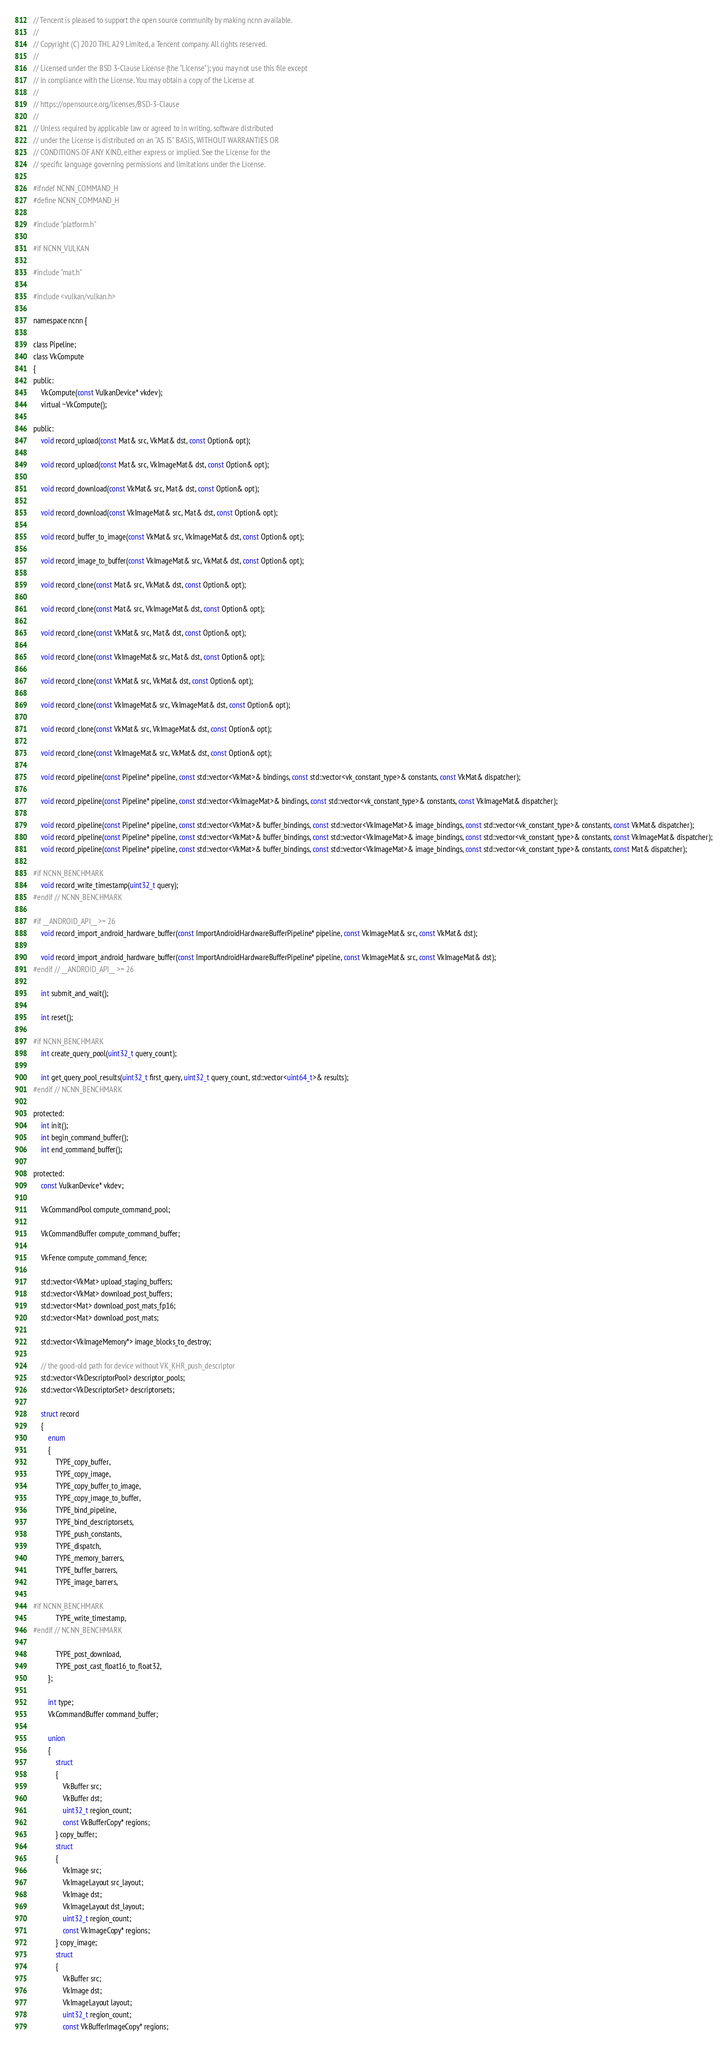<code> <loc_0><loc_0><loc_500><loc_500><_C_>// Tencent is pleased to support the open source community by making ncnn available.
//
// Copyright (C) 2020 THL A29 Limited, a Tencent company. All rights reserved.
//
// Licensed under the BSD 3-Clause License (the "License"); you may not use this file except
// in compliance with the License. You may obtain a copy of the License at
//
// https://opensource.org/licenses/BSD-3-Clause
//
// Unless required by applicable law or agreed to in writing, software distributed
// under the License is distributed on an "AS IS" BASIS, WITHOUT WARRANTIES OR
// CONDITIONS OF ANY KIND, either express or implied. See the License for the
// specific language governing permissions and limitations under the License.

#ifndef NCNN_COMMAND_H
#define NCNN_COMMAND_H

#include "platform.h"

#if NCNN_VULKAN

#include "mat.h"

#include <vulkan/vulkan.h>

namespace ncnn {

class Pipeline;
class VkCompute
{
public:
    VkCompute(const VulkanDevice* vkdev);
    virtual ~VkCompute();

public:
    void record_upload(const Mat& src, VkMat& dst, const Option& opt);

    void record_upload(const Mat& src, VkImageMat& dst, const Option& opt);

    void record_download(const VkMat& src, Mat& dst, const Option& opt);

    void record_download(const VkImageMat& src, Mat& dst, const Option& opt);

    void record_buffer_to_image(const VkMat& src, VkImageMat& dst, const Option& opt);

    void record_image_to_buffer(const VkImageMat& src, VkMat& dst, const Option& opt);

    void record_clone(const Mat& src, VkMat& dst, const Option& opt);

    void record_clone(const Mat& src, VkImageMat& dst, const Option& opt);

    void record_clone(const VkMat& src, Mat& dst, const Option& opt);

    void record_clone(const VkImageMat& src, Mat& dst, const Option& opt);

    void record_clone(const VkMat& src, VkMat& dst, const Option& opt);

    void record_clone(const VkImageMat& src, VkImageMat& dst, const Option& opt);

    void record_clone(const VkMat& src, VkImageMat& dst, const Option& opt);

    void record_clone(const VkImageMat& src, VkMat& dst, const Option& opt);

    void record_pipeline(const Pipeline* pipeline, const std::vector<VkMat>& bindings, const std::vector<vk_constant_type>& constants, const VkMat& dispatcher);

    void record_pipeline(const Pipeline* pipeline, const std::vector<VkImageMat>& bindings, const std::vector<vk_constant_type>& constants, const VkImageMat& dispatcher);

    void record_pipeline(const Pipeline* pipeline, const std::vector<VkMat>& buffer_bindings, const std::vector<VkImageMat>& image_bindings, const std::vector<vk_constant_type>& constants, const VkMat& dispatcher);
    void record_pipeline(const Pipeline* pipeline, const std::vector<VkMat>& buffer_bindings, const std::vector<VkImageMat>& image_bindings, const std::vector<vk_constant_type>& constants, const VkImageMat& dispatcher);
    void record_pipeline(const Pipeline* pipeline, const std::vector<VkMat>& buffer_bindings, const std::vector<VkImageMat>& image_bindings, const std::vector<vk_constant_type>& constants, const Mat& dispatcher);

#if NCNN_BENCHMARK
    void record_write_timestamp(uint32_t query);
#endif // NCNN_BENCHMARK

#if __ANDROID_API__ >= 26
    void record_import_android_hardware_buffer(const ImportAndroidHardwareBufferPipeline* pipeline, const VkImageMat& src, const VkMat& dst);

    void record_import_android_hardware_buffer(const ImportAndroidHardwareBufferPipeline* pipeline, const VkImageMat& src, const VkImageMat& dst);
#endif // __ANDROID_API__ >= 26

    int submit_and_wait();

    int reset();

#if NCNN_BENCHMARK
    int create_query_pool(uint32_t query_count);

    int get_query_pool_results(uint32_t first_query, uint32_t query_count, std::vector<uint64_t>& results);
#endif // NCNN_BENCHMARK

protected:
    int init();
    int begin_command_buffer();
    int end_command_buffer();

protected:
    const VulkanDevice* vkdev;

    VkCommandPool compute_command_pool;

    VkCommandBuffer compute_command_buffer;

    VkFence compute_command_fence;

    std::vector<VkMat> upload_staging_buffers;
    std::vector<VkMat> download_post_buffers;
    std::vector<Mat> download_post_mats_fp16;
    std::vector<Mat> download_post_mats;

    std::vector<VkImageMemory*> image_blocks_to_destroy;

    // the good-old path for device without VK_KHR_push_descriptor
    std::vector<VkDescriptorPool> descriptor_pools;
    std::vector<VkDescriptorSet> descriptorsets;

    struct record
    {
        enum
        {
            TYPE_copy_buffer,
            TYPE_copy_image,
            TYPE_copy_buffer_to_image,
            TYPE_copy_image_to_buffer,
            TYPE_bind_pipeline,
            TYPE_bind_descriptorsets,
            TYPE_push_constants,
            TYPE_dispatch,
            TYPE_memory_barrers,
            TYPE_buffer_barrers,
            TYPE_image_barrers,

#if NCNN_BENCHMARK
            TYPE_write_timestamp,
#endif // NCNN_BENCHMARK

            TYPE_post_download,
            TYPE_post_cast_float16_to_float32,
        };

        int type;
        VkCommandBuffer command_buffer;

        union
        {
            struct
            {
                VkBuffer src;
                VkBuffer dst;
                uint32_t region_count;
                const VkBufferCopy* regions;
            } copy_buffer;
            struct
            {
                VkImage src;
                VkImageLayout src_layout;
                VkImage dst;
                VkImageLayout dst_layout;
                uint32_t region_count;
                const VkImageCopy* regions;
            } copy_image;
            struct
            {
                VkBuffer src;
                VkImage dst;
                VkImageLayout layout;
                uint32_t region_count;
                const VkBufferImageCopy* regions;</code> 